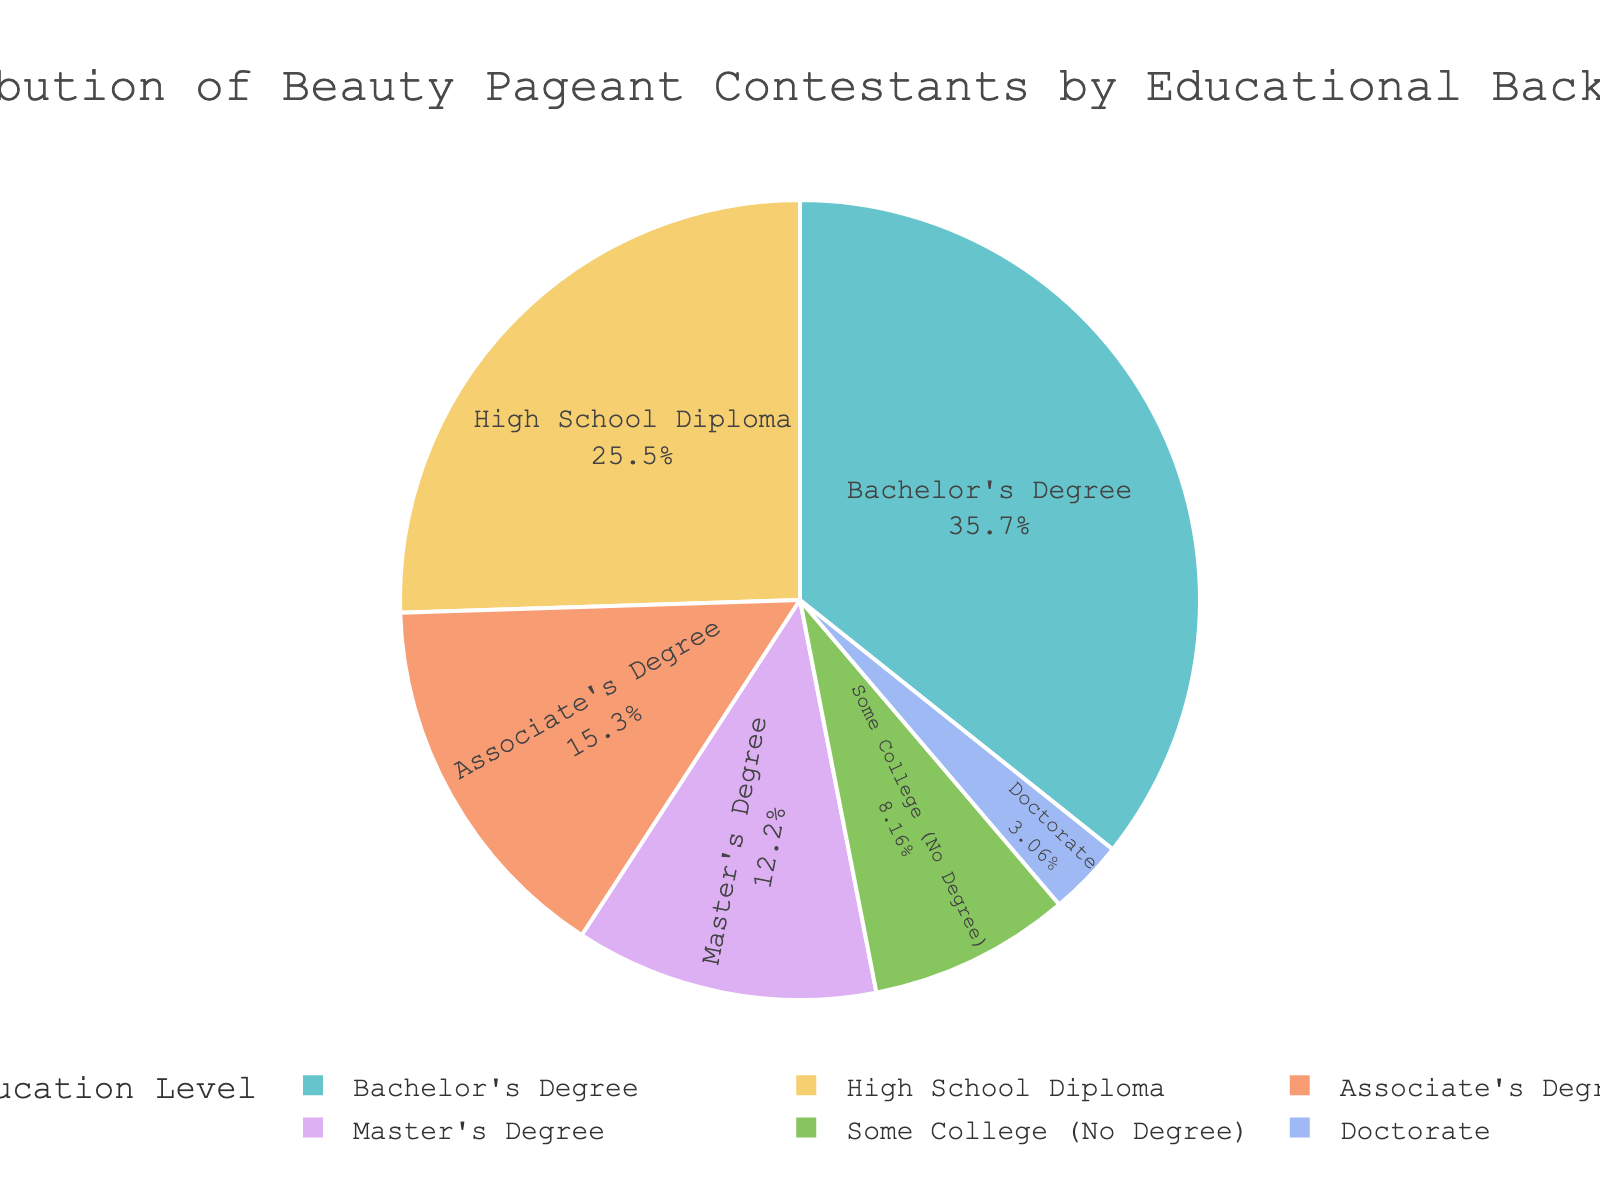What is the percentage of beauty pageant contestants with a Bachelor's Degree? Look at the pie chart slice labeled "Bachelor's Degree" and check the percentage value associated with it.
Answer: 35% Which educational background category has the smallest representation among beauty pageant contestants? View the pie chart and identify the slice with the smallest percentage.
Answer: Doctorate What is the combined percentage of contestants with a Master's Degree and Some College (No Degree)? Add the percentages of "Master's Degree" and "Some College (No Degree)" slices from the chart: 12% + 8%.
Answer: 20% Is the percentage of contestants with a High School Diploma greater than those with an Associate's Degree? Compare the percentages from the High School Diploma slice (25%) and the Associate's Degree slice (15%).
Answer: Yes What proportion of contestants have attained education up to the Bachelor's level or higher? Sum the percentages for Bachelor's Degree, Master's Degree, and Doctorate: 35% + 12% + 3%.
Answer: 50% How much larger is the percentage of contestants with a Bachelor's Degree compared to those with a Doctorate? Subtract the percentage of Doctorate holders (3%) from Bachelor's Degree holders (35%): 35% - 3%.
Answer: 32% What educational backgrounds make up more than a quarter of the contestants combined? Add the percentages of categories and see which subset totals more than 25%. "Bachelor's Degree" and "High School Diploma" combined is 35% + 25%.
Answer: Bachelor's Degree and High School Diploma Which category has a larger percentage: contestants with an Associate's Degree or those with Some College (No Degree)? Compare the slice percentages of "Associate's Degree" (15%) and "Some College (No Degree)" (8%).
Answer: Associate's Degree What is the difference in percentage between contestants with a Bachelor's Degree and those with a High School Diploma? Subtract the percentage of High School Diploma holders (25%) from Bachelor's Degree holders (35%): 35% - 25%.
Answer: 10% How many percentage points separate Master's Degree holders from Doctorate holders? Subtract the percentage of Doctorate holders (3%) from Master's Degree holders (12%): 12% - 3%.
Answer: 9% 